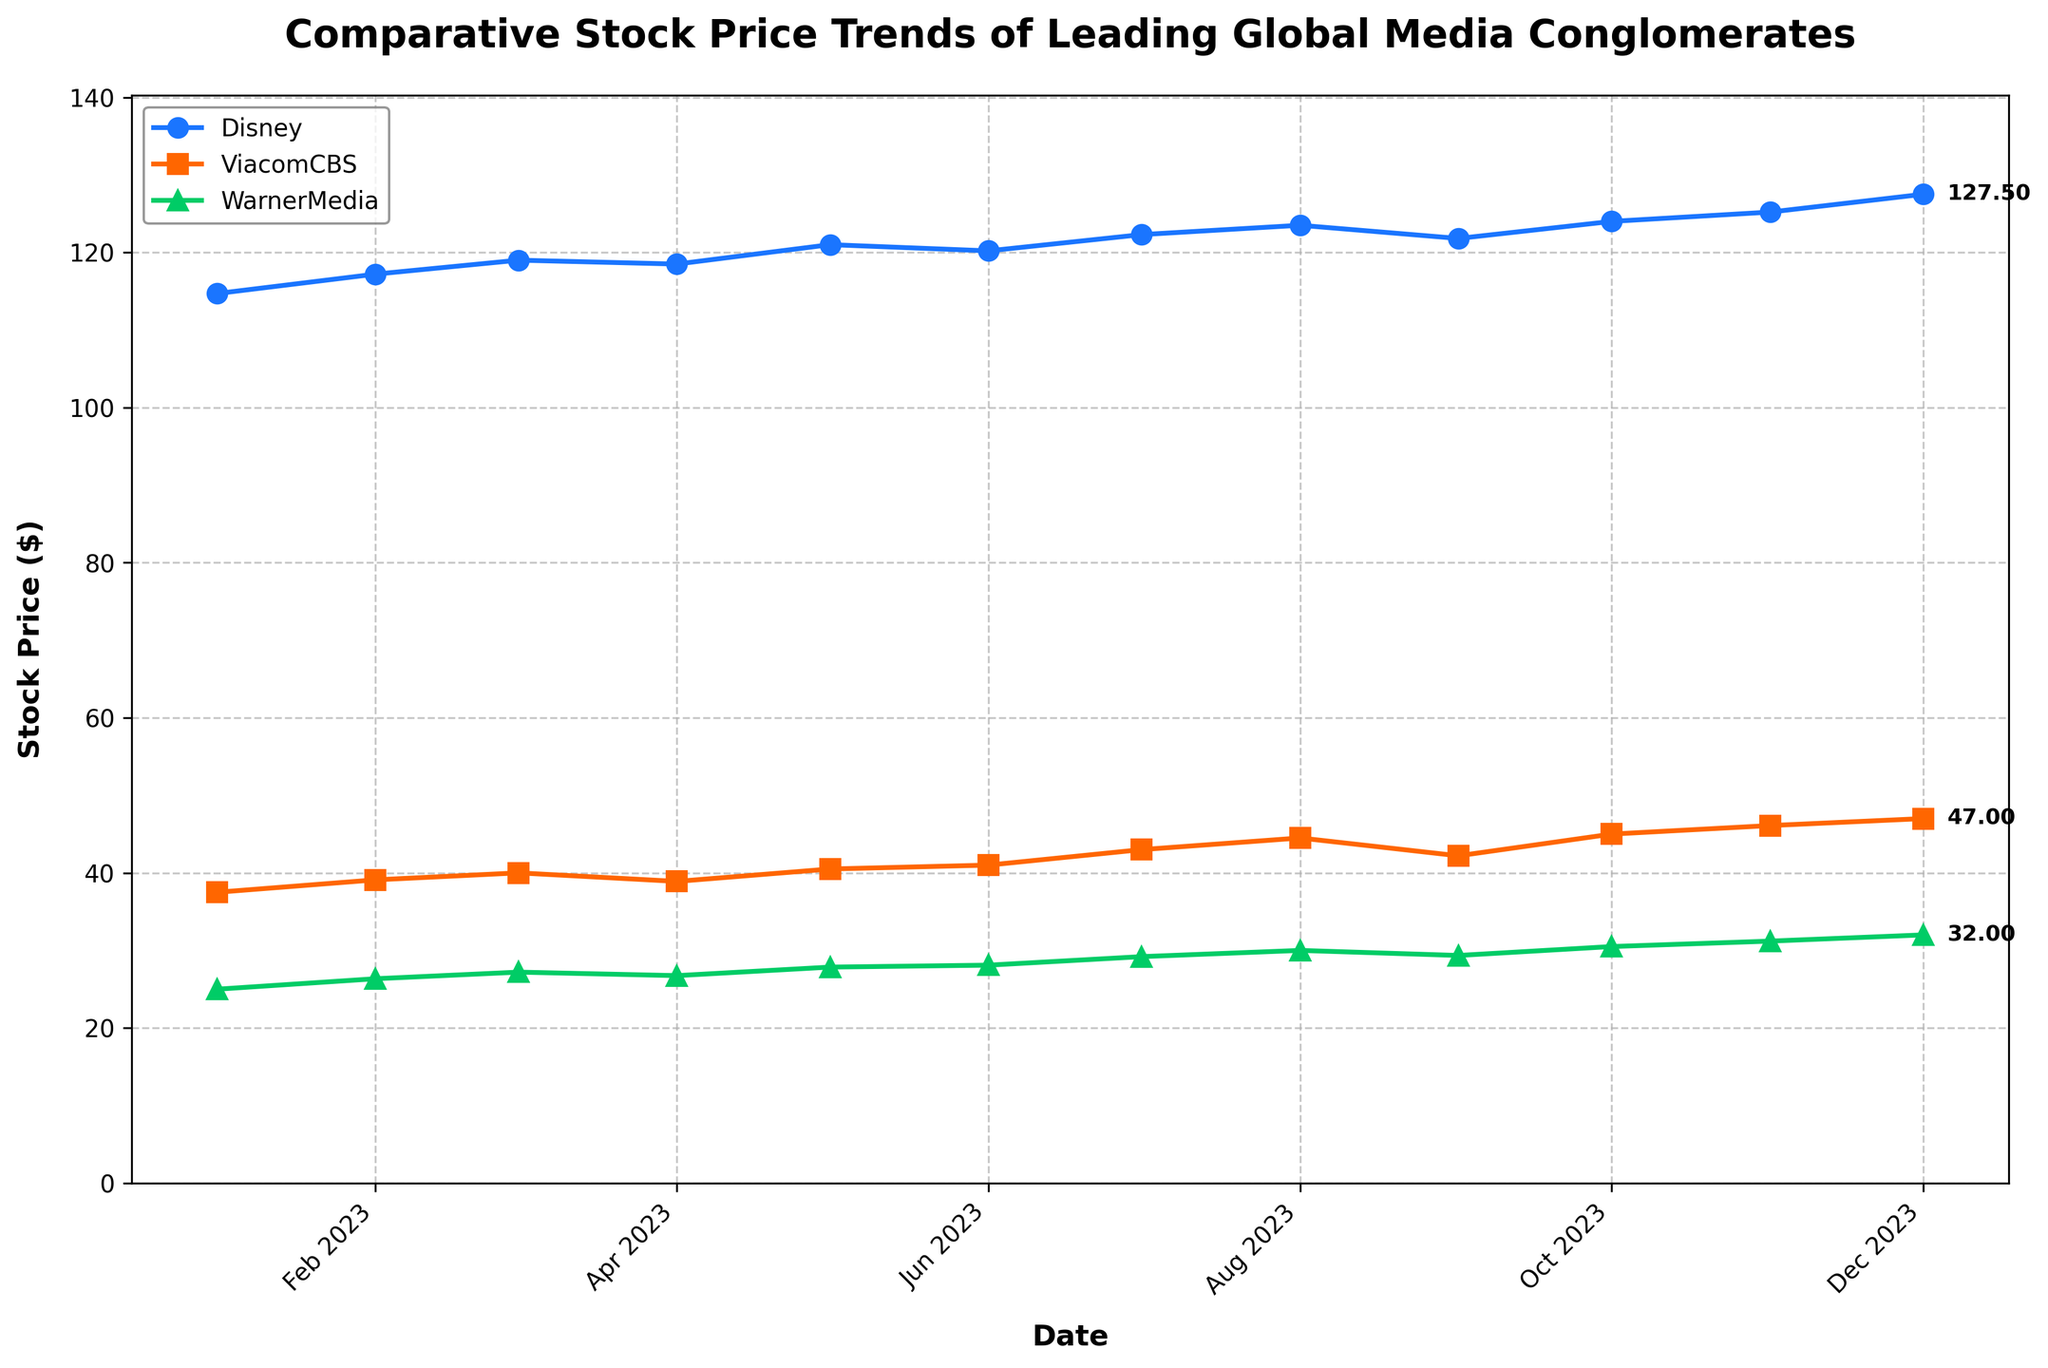What is the title of the plot? The title is displayed at the top of the plot. It is bold and descriptive of the content shown in the figure.
Answer: Comparative Stock Price Trends of Leading Global Media Conglomerates How many data points are there for each company? The x-axis shows dates from January to December 2023, indicating monthly data points.
Answer: 12 Which company had the highest stock price in December 2023? The y-axis shows stock prices, and from the plot, Disney’s stock price in December 2023 is the highest among the three companies.
Answer: Disney What is the general trend of WarnerMedia’s stock price throughout 2023? By observing the line labeled WarnerMedia with a distinct color and markers, the stock price has a consistent upward trend over the months.
Answer: Upward In which month did ViacomCBS surpass a stock price of $40 for the first time? The plot shows ViacomCBS's stock prices over time; it first surpassed $40 in May 2023.
Answer: May 2023 Approximately, how much did Disney's stock price increase from January to December 2023? Disney's stock price in January 2023 was $114.70 and rose to $127.50 by December. The increase is calculated as $127.50 - $114.70.
Answer: $12.80 Which company experienced the most substantial growth in stock price over the year? By comparing the endpoints of each company's stock prices in January and December, calculate the difference: Disney ($127.50 - $114.70), ViacomCBS ($47.00 - $37.50), WarnerMedia ($32.00 - $25.00). ViacomCBS had the highest increase.
Answer: ViacomCBS Between which two months did Disney's stock price see a decrease? By analyzing the plotted data points for Disney, the only apparent decrease is between March and April 2023.
Answer: March - April How does the stock price trend of ViacomCBS compare to WarnerMedia from September to December 2023? Both trends should be observed from September to December. ViacomCBS shows a continuous rise, whereas WarnerMedia also rises but at a steadier pace.
Answer: ViacomCBS rises faster What is the average stock price of WarnerMedia over the year 2023? Sum WarnerMedia's stock prices from each month and then divide by 12: (25 + 26.35 + 27.2 + 26.75 + 27.85 + 28.1 + 29.2 + 30 + 29.35 + 30.5 + 31.2 + 32)/12.
Answer: 28.45 